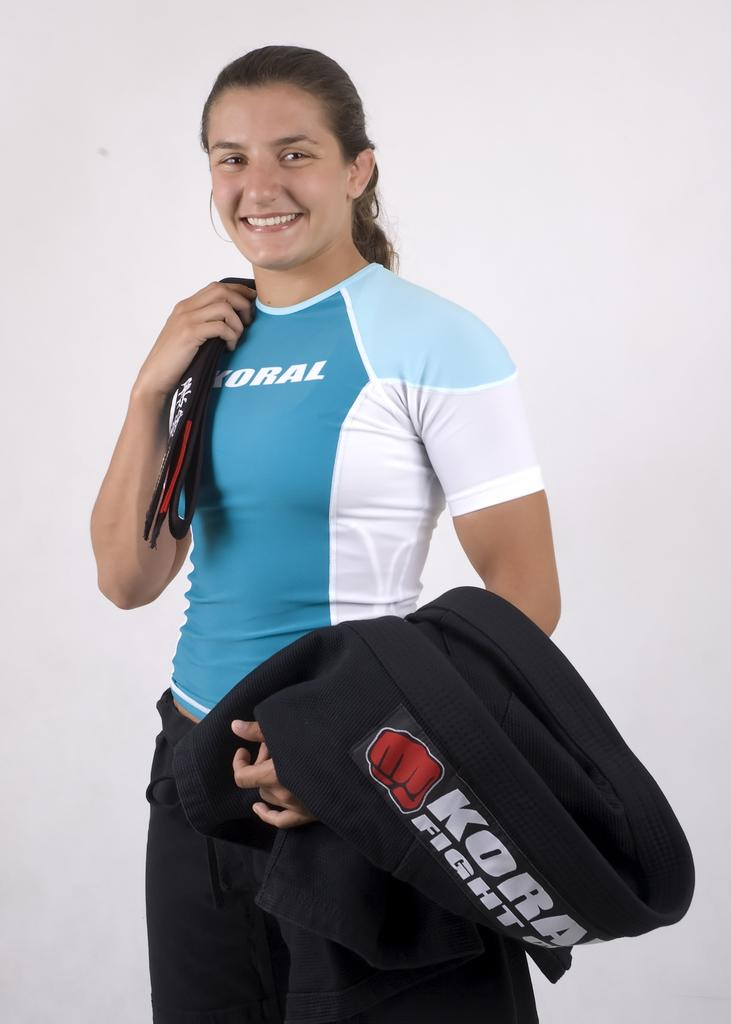<image>
Offer a succinct explanation of the picture presented. A fighter girl is posing for a Koral Fight gear photo. 